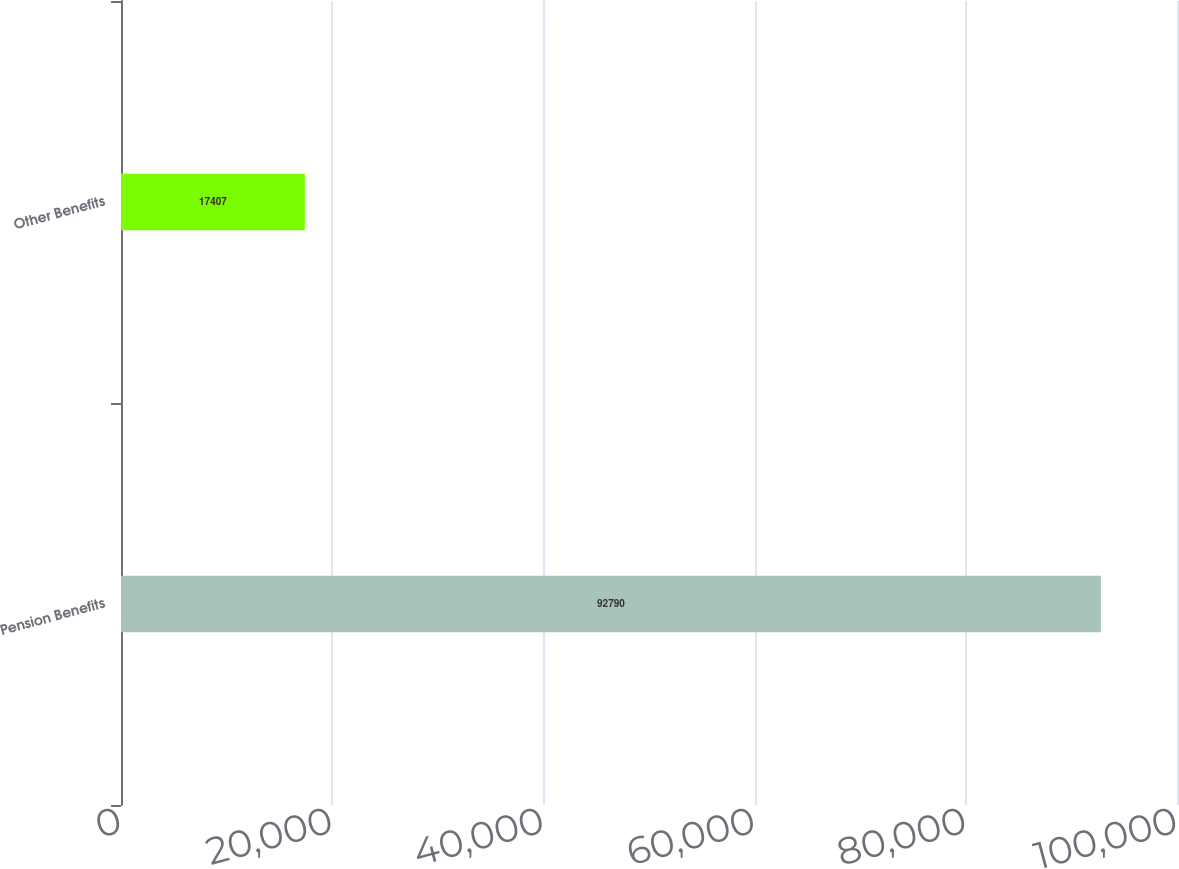Convert chart. <chart><loc_0><loc_0><loc_500><loc_500><bar_chart><fcel>Pension Benefits<fcel>Other Benefits<nl><fcel>92790<fcel>17407<nl></chart> 